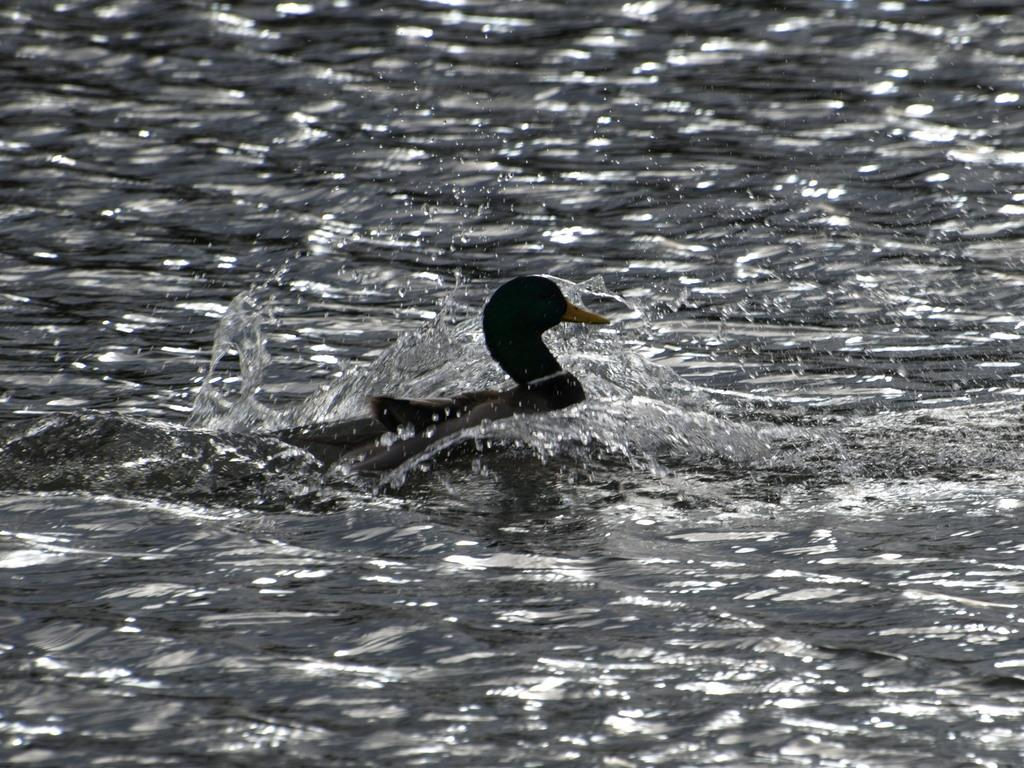What animal is present in the image? There is a duck in the image. Where is the duck located? The duck is in the water. What is the color scheme of the image? The image is black and white. What type of trade is happening between the ducks in the image? There are no other ducks present in the image, and therefore no trade can be observed. Can you describe the clouds in the image? There are no clouds present in the image, as it is a black and white image of a duck in the water. 